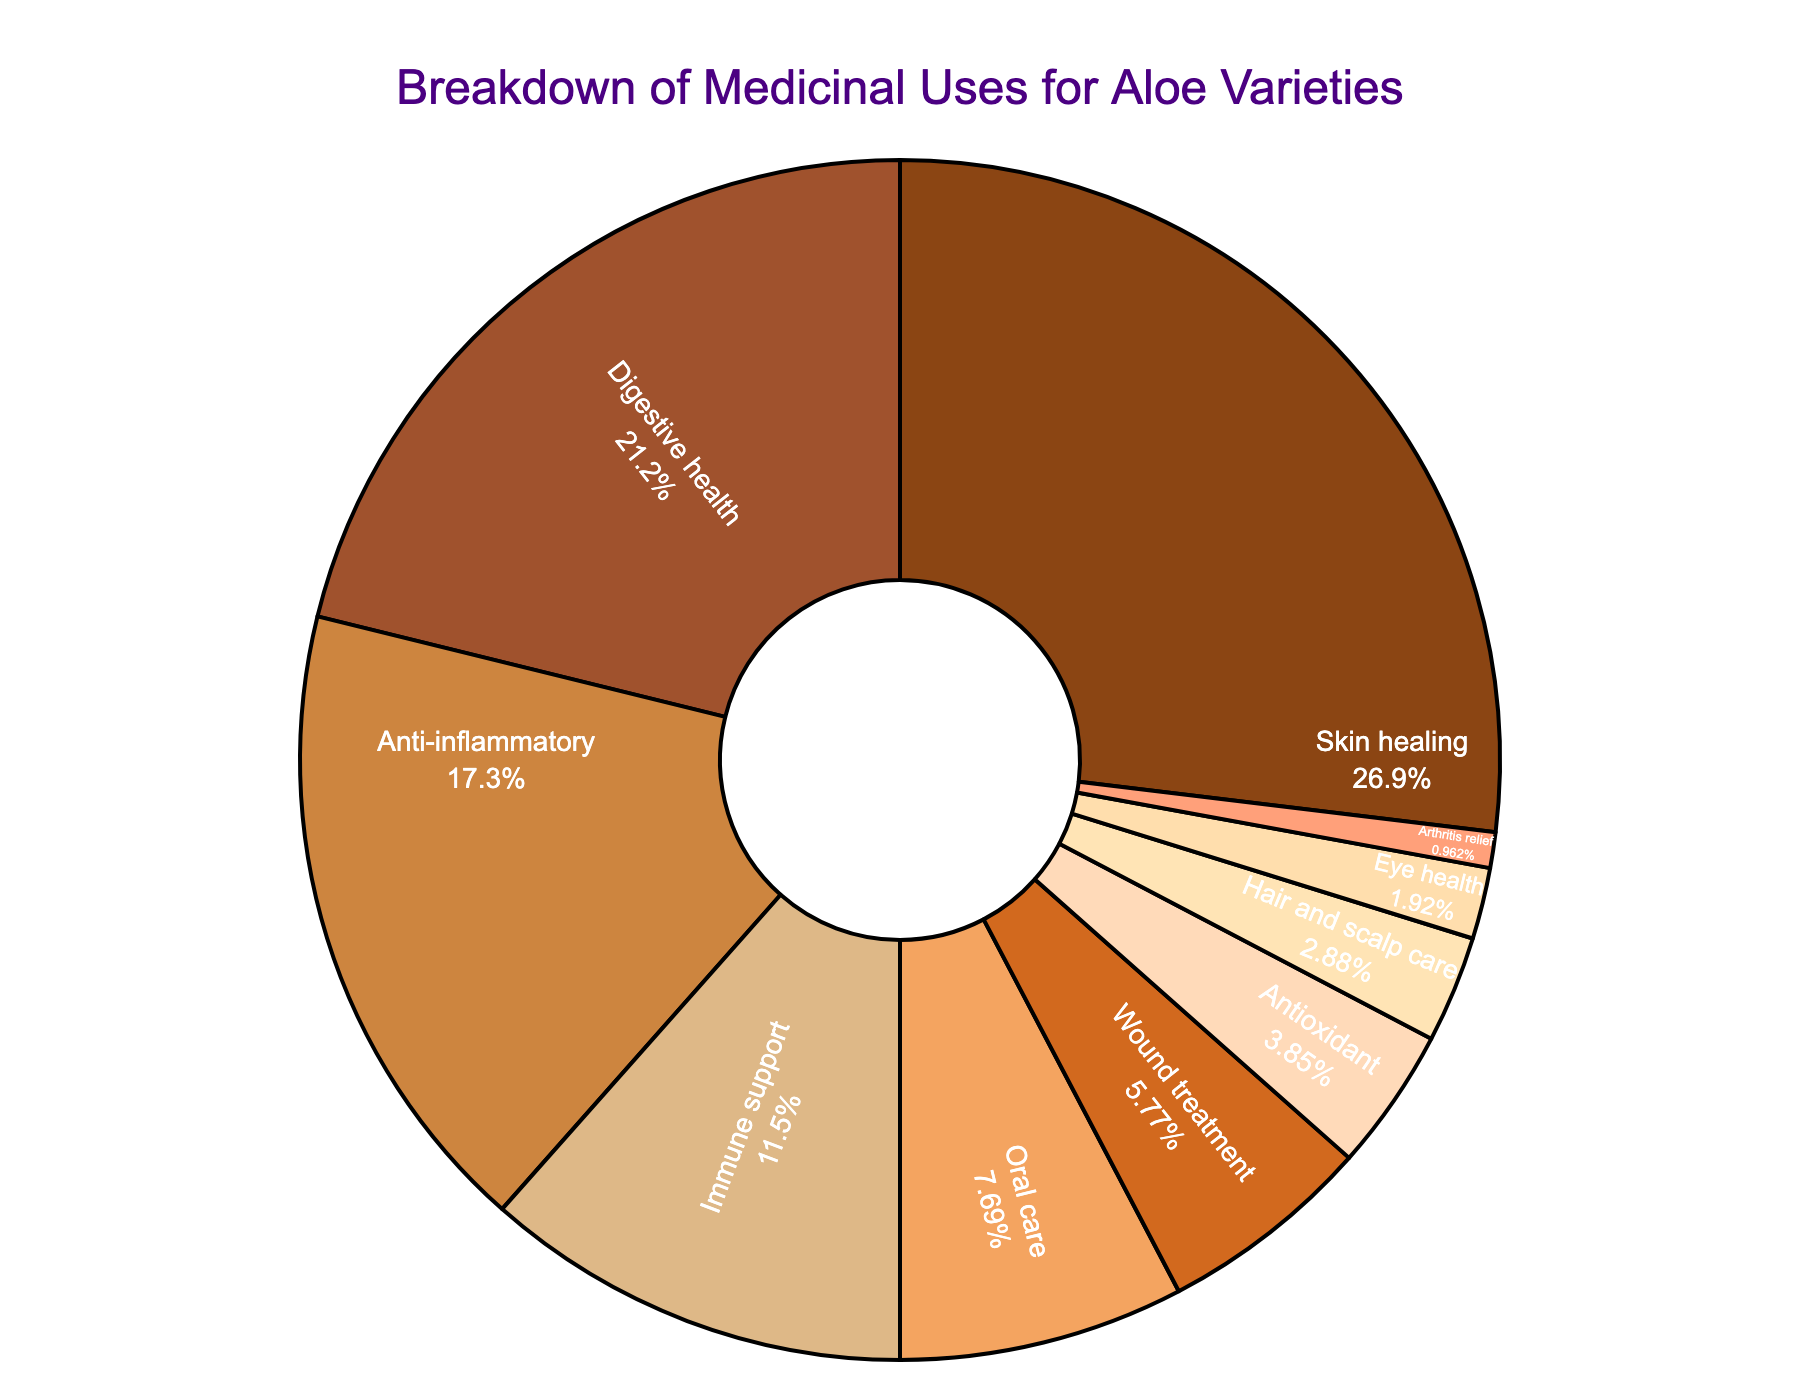What medicinal use has the highest percentage? Look at the largest segment of the pie chart, which represents the medicinal use with the largest percentage. The label shows "Skin healing" at 28%.
Answer: Skin healing Which medicinal use has the lowest percentage? Examine the smallest segment of the pie chart, which will represent the medicinal use with the smallest percentage. The label shows "Arthritis relief" at 1%.
Answer: Arthritis relief What is the combined percentage of Oral care, Wound treatment, and Hair and scalp care? Add the individual percentages of these three categories: 8% (Oral care) + 6% (Wound treatment) + 3% (Hair and scalp care) = 17%.
Answer: 17% Which medicinal use categories together make up more than 50% of the pie chart? Combine the largest percentages until the sum exceeds 50%. Skin healing (28%) + Digestive health (22%) = 50%, immediately hitting the half mark. So, these two categories together make up more than 50%.
Answer: Skin healing and Digestive health Is Anti-inflammatory more or less than twice the percentage of Eye health? Double the percentage of Eye health (2%) and compare it with the percentage of Anti-inflammatory (18%). 2% * 2 = 4%. Anti-inflammatory (18%) is greater than double Eye health (4%).
Answer: More Compare the percentages of Digestive health and Immune support. Which one is greater? Look at the pie chart and note the percentages for Digestive health at 22% and Immune support at 12%. Digestive health is greater.
Answer: Digestive health What percentage of the pie chart does Anti-inflammatory and Antioxidant together comprise? Add the percentages of Anti-inflammatory (18%) and Antioxidant (4%): 18% + 4% = 22%.
Answer: 22% How much more is Skin healing compared to Oral care? Subtract the percentage of Oral care (8%) from Skin healing (28%): 28% - 8% = 20%.
Answer: 20% What is the second least represented medicinal use in the pie chart? Identify the second smallest segment after Arthritis relief (1%). The next smallest segment is Eye health at 2%.
Answer: Eye health List the medicinal uses that are less than 5% of the pie chart. Identify segments with percentages less than 5%. These include Antioxidant (4%), Hair and scalp care (3%), Eye health (2%), and Arthritis relief (1%).
Answer: Antioxidant, Hair and scalp care, Eye health, Arthritis relief 